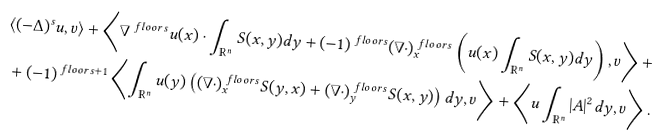<formula> <loc_0><loc_0><loc_500><loc_500>& \langle ( - \Delta ) ^ { s } u , v \rangle + \left \langle \nabla ^ { \ f l o o r { s } } u ( x ) \cdot \int _ { \mathbb { R } ^ { n } } S ( x , y ) d y + ( - 1 ) ^ { \ f l o o r { s } } ( \nabla \cdot ) _ { x } ^ { \ f l o o r { s } } \left ( u ( x ) \int _ { \mathbb { R } ^ { n } } S ( x , y ) d y \right ) , v \right \rangle + \\ & + ( - 1 ) ^ { \ f l o o r { s } + 1 } \left \langle \int _ { \mathbb { R } ^ { n } } u ( y ) \left ( ( \nabla \cdot ) _ { x } ^ { \ f l o o r { s } } S ( y , x ) + ( \nabla \cdot ) _ { y } ^ { \ f l o o r { s } } S ( x , y ) \right ) d y , v \right \rangle + \left \langle u \int _ { \mathbb { R } ^ { n } } | A | ^ { 2 } d y , v \right \rangle .</formula> 